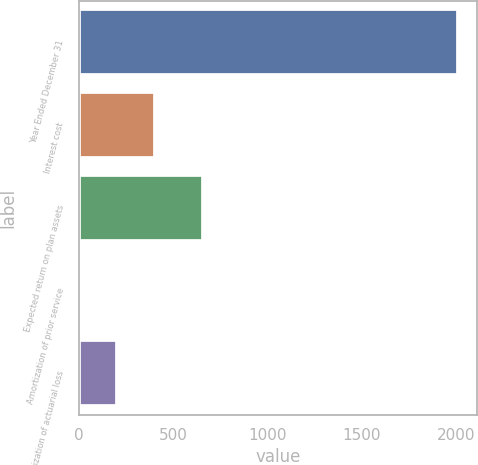Convert chart. <chart><loc_0><loc_0><loc_500><loc_500><bar_chart><fcel>Year Ended December 31<fcel>Interest cost<fcel>Expected return on plan assets<fcel>Amortization of prior service<fcel>Amortization of actuarial loss<nl><fcel>2013<fcel>404.2<fcel>659<fcel>2<fcel>203.1<nl></chart> 